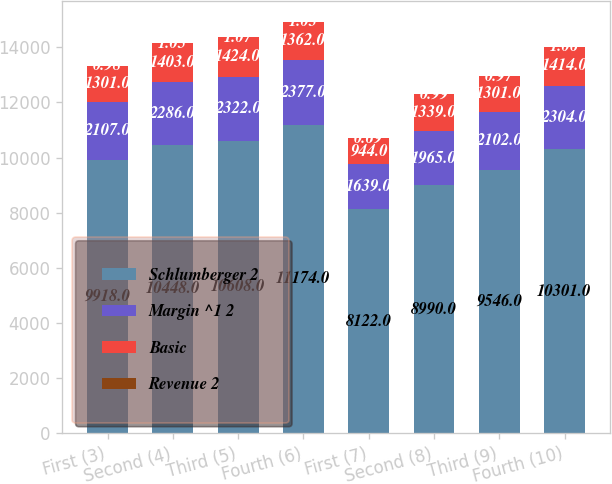Convert chart to OTSL. <chart><loc_0><loc_0><loc_500><loc_500><stacked_bar_chart><ecel><fcel>First (3)<fcel>Second (4)<fcel>Third (5)<fcel>Fourth (6)<fcel>First (7)<fcel>Second (8)<fcel>Third (9)<fcel>Fourth (10)<nl><fcel>Schlumberger 2<fcel>9918<fcel>10448<fcel>10608<fcel>11174<fcel>8122<fcel>8990<fcel>9546<fcel>10301<nl><fcel>Margin ^1 2<fcel>2107<fcel>2286<fcel>2322<fcel>2377<fcel>1639<fcel>1965<fcel>2102<fcel>2304<nl><fcel>Basic<fcel>1301<fcel>1403<fcel>1424<fcel>1362<fcel>944<fcel>1339<fcel>1301<fcel>1414<nl><fcel>Revenue 2<fcel>0.98<fcel>1.05<fcel>1.07<fcel>1.03<fcel>0.69<fcel>0.99<fcel>0.97<fcel>1.06<nl></chart> 